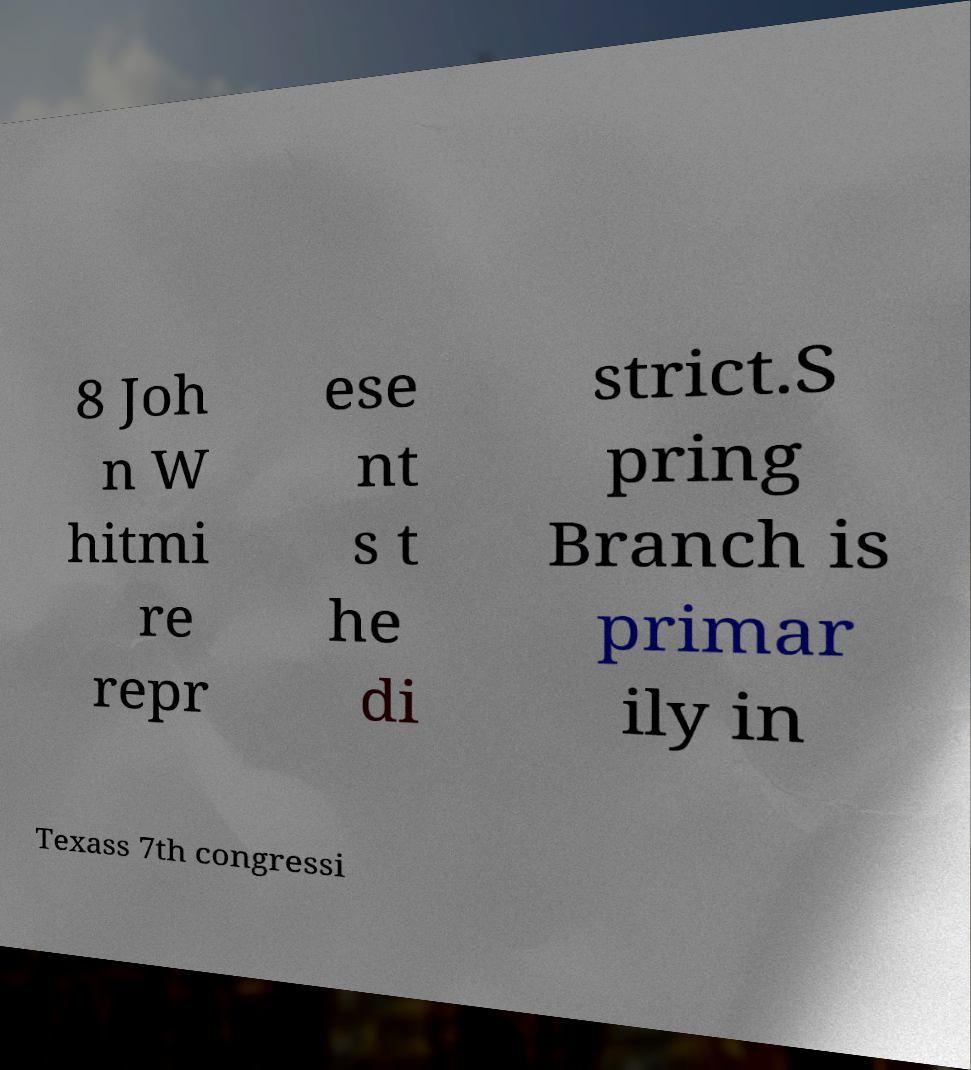What messages or text are displayed in this image? I need them in a readable, typed format. 8 Joh n W hitmi re repr ese nt s t he di strict.S pring Branch is primar ily in Texass 7th congressi 